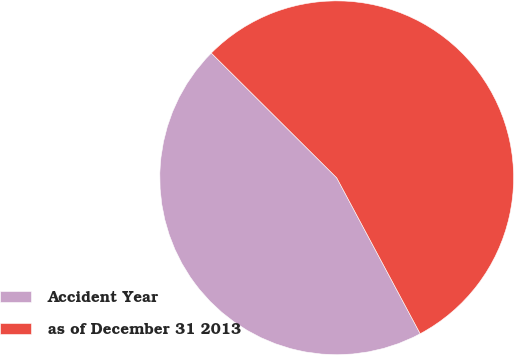<chart> <loc_0><loc_0><loc_500><loc_500><pie_chart><fcel>Accident Year<fcel>as of December 31 2013<nl><fcel>45.28%<fcel>54.72%<nl></chart> 